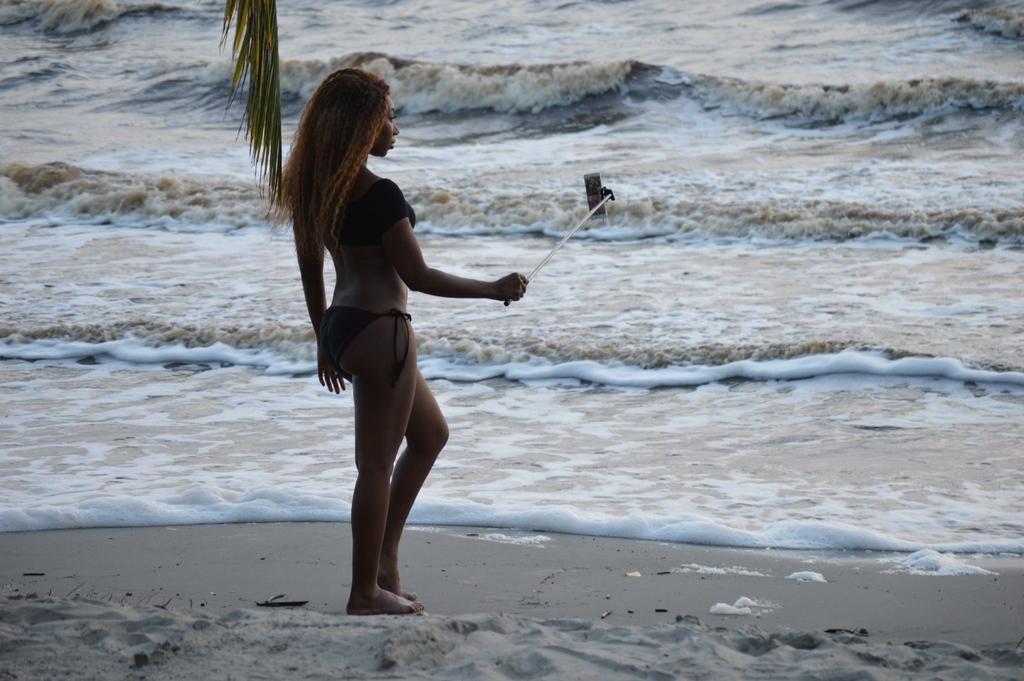Who is present in the image? There is a woman in the image. What is the woman standing on? The woman is standing on the sand. What is the woman holding in the image? The woman is holding a selfie stick. What can be seen in the background of the image? There is water visible in the background. What is located at the top of the image? There is a branch of a tree at the top of the image. What type of company is visible in the image? There is no company present in the image; it features a woman standing on the sand, holding a selfie stick, with water and a tree branch visible in the background. How many snakes can be seen in the image? There are no snakes present in the image. 